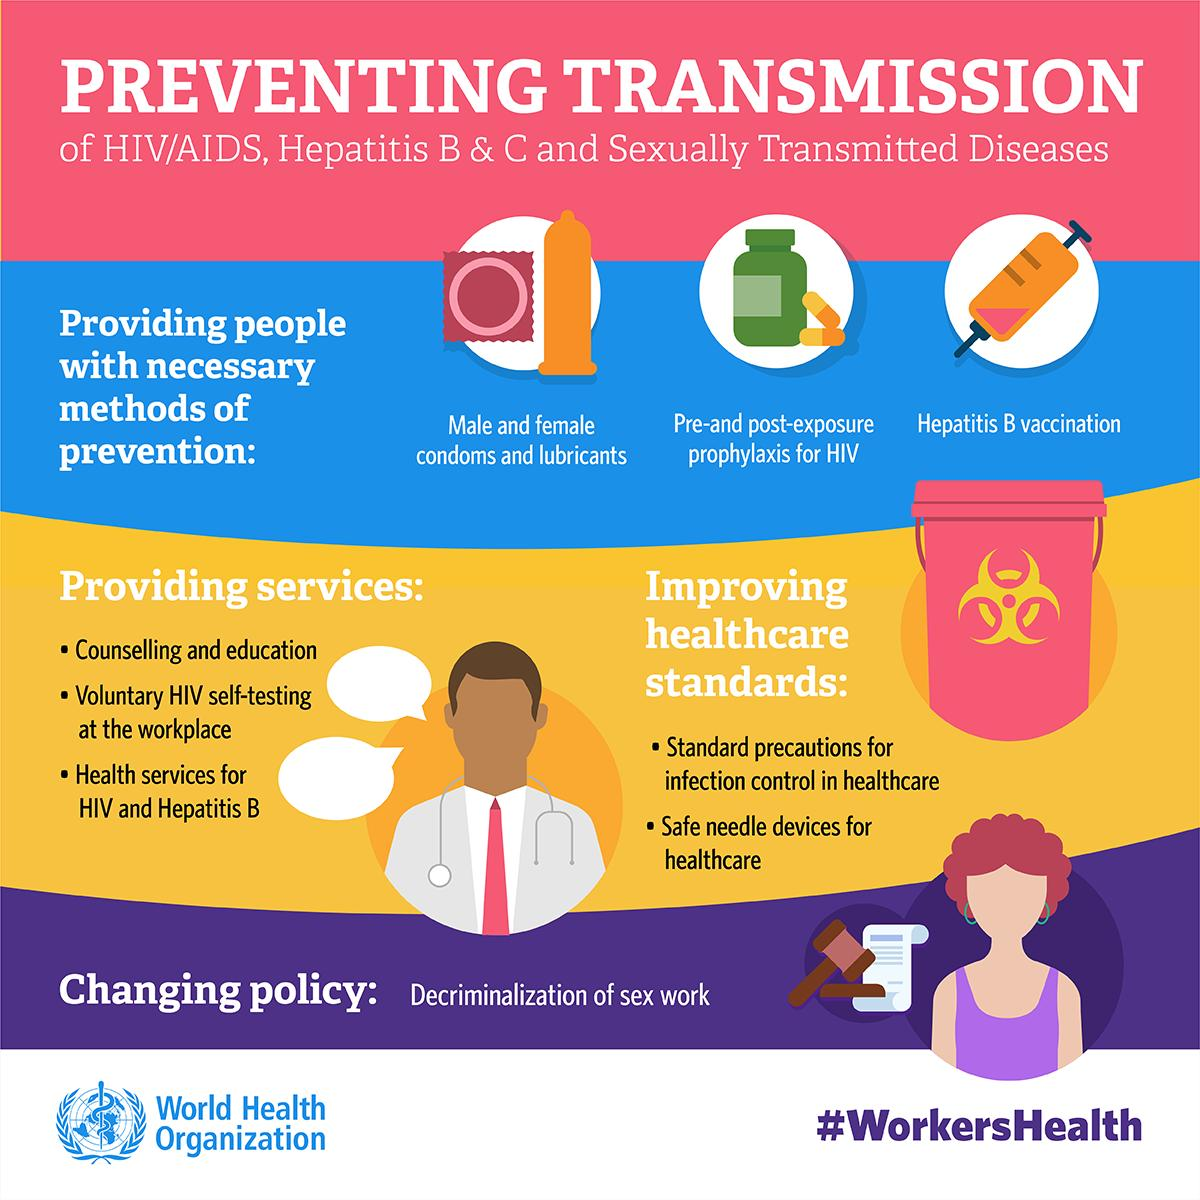Mention a couple of crucial points in this snapshot. There are three ways of prevention demonstrated. The implementation of standard precautions for infection control in healthcare, the use of safe needle devices, and other measures to improve healthcare standards should be prioritized in order to enhance the overall quality of care and protect patients from infection and other harmful outcomes. Thirty-three services have been highlighted. 